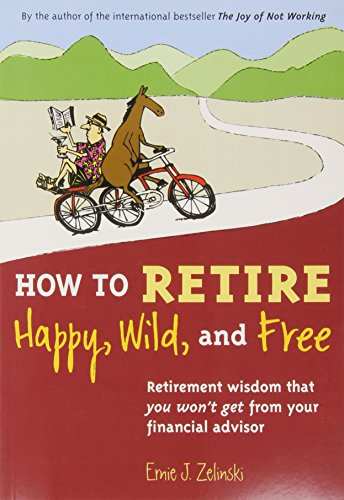Is this a fitness book? While it falls under the category of 'Health, Fitness & Dieting,' it is not a fitness book in the traditional sense; it rather focuses on achieving a satisfying and joyful retirement lifestyle. 